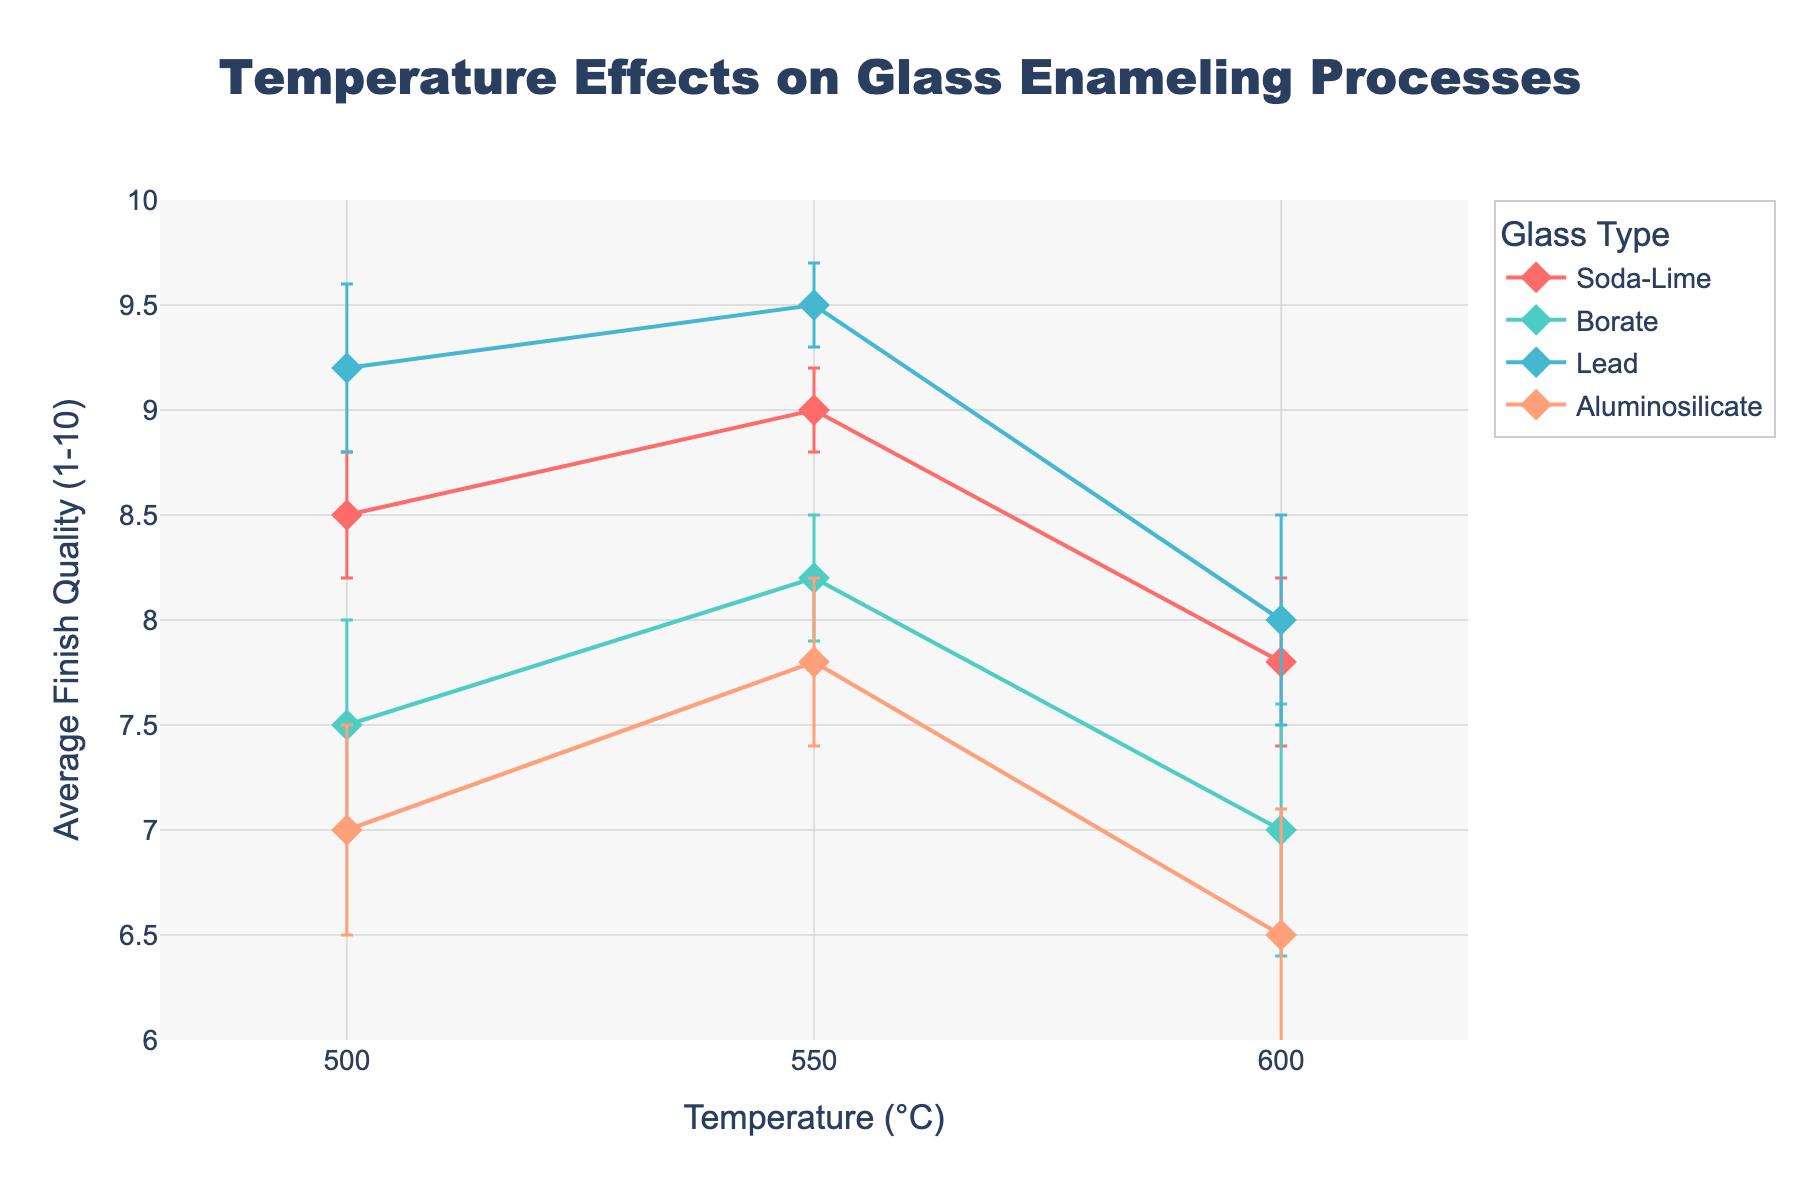What's the title of the plot? The title is found at the top of the plot. It is usually larger and bolder than other text in the plot.
Answer: Temperature Effects on Glass Enameling Processes What does the y-axis represent? Check the label of the y-axis on the left side of the plot.
Answer: Average Finish Quality (1-10) Which glass type has the highest finish quality at 550°C? Find the data points for each glass type at 550°C, then identify which one has the highest value.
Answer: Lead How does the average finish quality of Soda-Lime glass change from 500°C to 600°C? Look at the data points for Soda-Lime glass at 500°C, 550°C, and 600°C and compare the values.
Answer: Decreases from 8.5 to 7.8 What is the error range for Borate glass at 600°C? Locate the data point for Borate glass at 600°C and check the error bars indicating the error range.
Answer: 0.6 Among all glass types, which has the smallest error range across all temperatures? Compare the error ranges provided for each glass type at all recorded temperatures and identify the smallest.
Answer: Soda-Lime At which temperature does Aluminosilicate glass have a finish quality of about 7.8? Check the data points for Aluminosilicate glass and identify the temperature where the finish quality is approximately 7.8.
Answer: 550°C Which glass type shows the largest decrease in finish quality between 550°C and 600°C? Calculate the difference in finish quality between 550°C and 600°C for each glass type and identify the largest decrease.
Answer: Borate How many data points are plotted for each glass type? Count the number of data points (markers) for each glass type in the plot.
Answer: 3 What is the average finish quality of Lead glass across all temperatures? Sum the finish quality values for Lead glass at 500°C, 550°C, and 600°C, then divide by the number of data points. \( (9.2 + 9.5 + 8.0)/3 \)
Answer: 8.9 